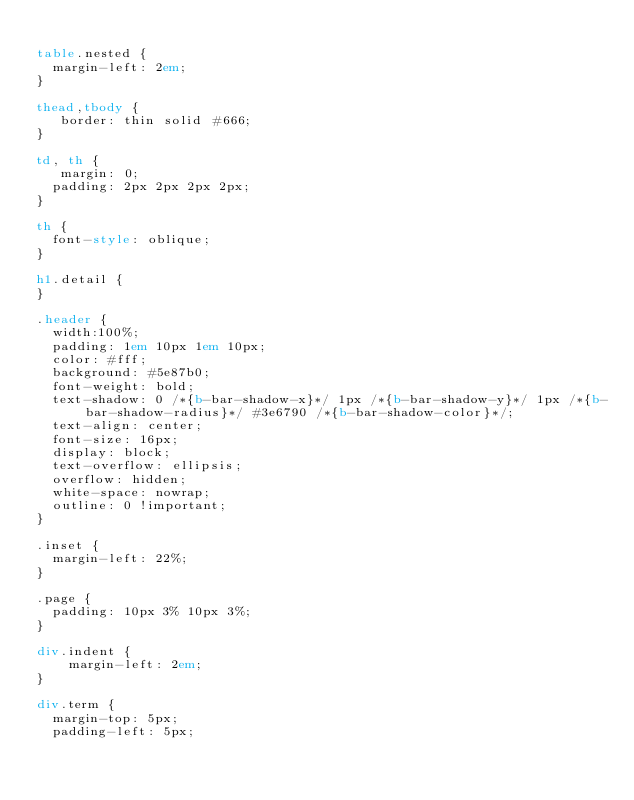Convert code to text. <code><loc_0><loc_0><loc_500><loc_500><_HTML_>
table.nested {
	margin-left: 2em;
}

thead,tbody {
   border: thin solid #666;
}

td, th {
   margin: 0;
	padding: 2px 2px 2px 2px;
}

th {
	font-style: oblique;
}

h1.detail {
}

.header {
	width:100%;
	padding: 1em 10px 1em 10px;
	color: #fff;
	background: #5e87b0;
	font-weight: bold;
	text-shadow: 0 /*{b-bar-shadow-x}*/ 1px /*{b-bar-shadow-y}*/ 1px /*{b-bar-shadow-radius}*/ #3e6790 /*{b-bar-shadow-color}*/;
	text-align: center;
	font-size: 16px;
	display: block;
	text-overflow: ellipsis;
	overflow: hidden;
	white-space: nowrap;
	outline: 0 !important;
}

.inset {
	margin-left: 22%;
}

.page {
	padding: 10px 3% 10px 3%;
}

div.indent {
    margin-left: 2em;
}

div.term {
	margin-top: 5px;
	padding-left: 5px;</code> 